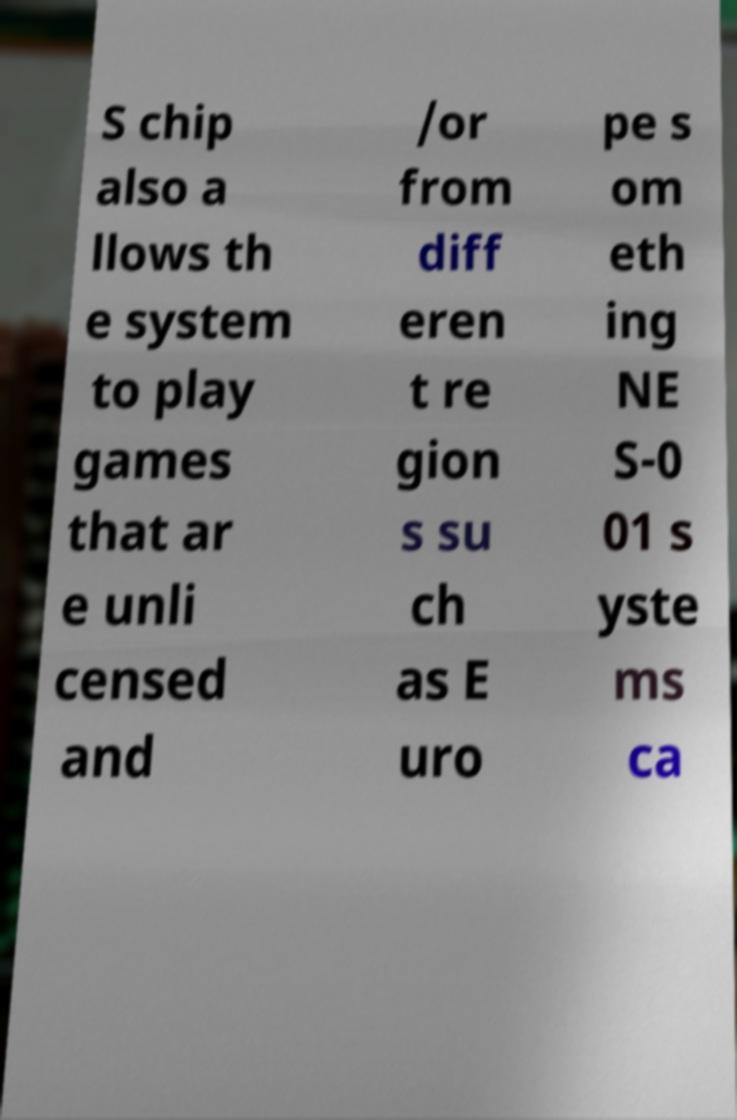Could you assist in decoding the text presented in this image and type it out clearly? S chip also a llows th e system to play games that ar e unli censed and /or from diff eren t re gion s su ch as E uro pe s om eth ing NE S-0 01 s yste ms ca 